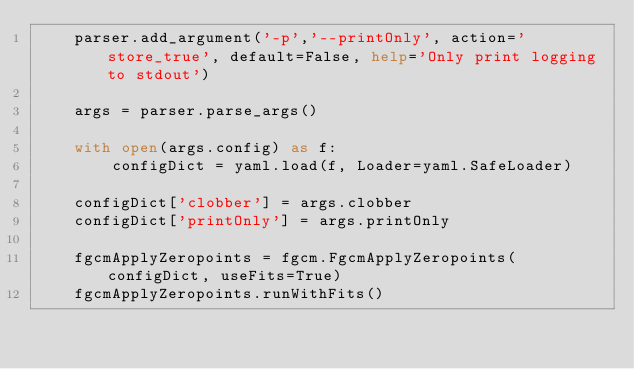Convert code to text. <code><loc_0><loc_0><loc_500><loc_500><_Python_>    parser.add_argument('-p','--printOnly', action='store_true', default=False, help='Only print logging to stdout')

    args = parser.parse_args()

    with open(args.config) as f:
        configDict = yaml.load(f, Loader=yaml.SafeLoader)

    configDict['clobber'] = args.clobber
    configDict['printOnly'] = args.printOnly

    fgcmApplyZeropoints = fgcm.FgcmApplyZeropoints(configDict, useFits=True)
    fgcmApplyZeropoints.runWithFits()
</code> 